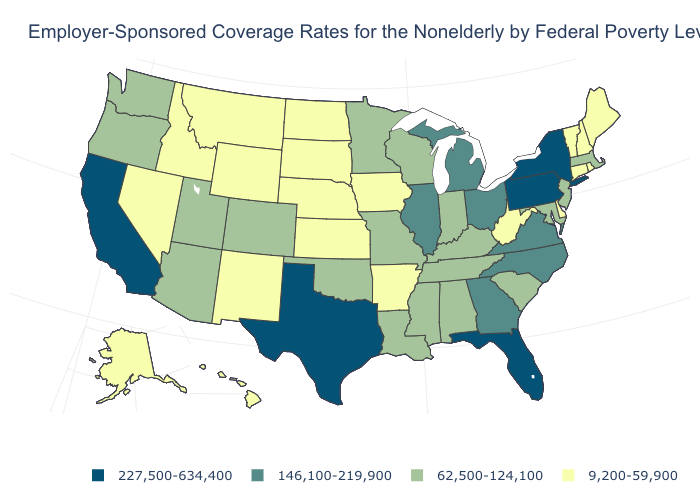Name the states that have a value in the range 9,200-59,900?
Give a very brief answer. Alaska, Arkansas, Connecticut, Delaware, Hawaii, Idaho, Iowa, Kansas, Maine, Montana, Nebraska, Nevada, New Hampshire, New Mexico, North Dakota, Rhode Island, South Dakota, Vermont, West Virginia, Wyoming. What is the value of Utah?
Short answer required. 62,500-124,100. What is the value of Mississippi?
Answer briefly. 62,500-124,100. Name the states that have a value in the range 227,500-634,400?
Be succinct. California, Florida, New York, Pennsylvania, Texas. How many symbols are there in the legend?
Keep it brief. 4. What is the value of Ohio?
Answer briefly. 146,100-219,900. How many symbols are there in the legend?
Concise answer only. 4. What is the lowest value in the West?
Keep it brief. 9,200-59,900. What is the value of Tennessee?
Write a very short answer. 62,500-124,100. What is the lowest value in states that border Oklahoma?
Quick response, please. 9,200-59,900. What is the lowest value in the USA?
Concise answer only. 9,200-59,900. What is the lowest value in states that border Montana?
Keep it brief. 9,200-59,900. Among the states that border Utah , does Wyoming have the highest value?
Answer briefly. No. Which states have the highest value in the USA?
Write a very short answer. California, Florida, New York, Pennsylvania, Texas. Does Texas have a lower value than Illinois?
Short answer required. No. 